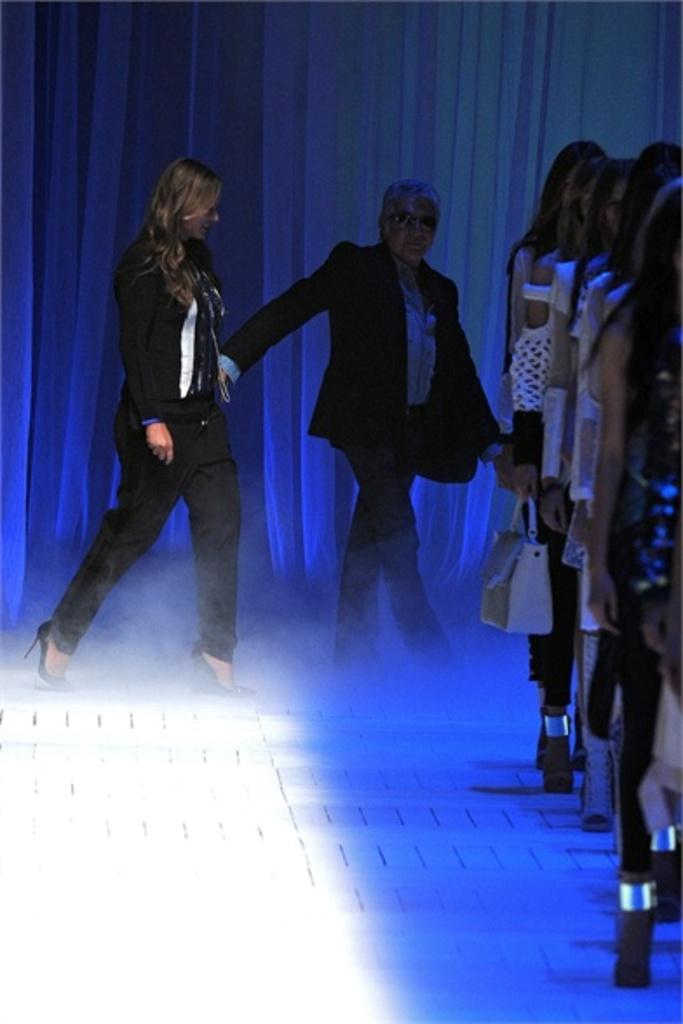What are the people on the right side of the image doing? The people on the right side of the image are standing. What are the two persons in the middle of the image doing? The two persons in the middle of the image are walking. What can be seen in the background of the image? There is a curtain in the background of the image. What is the temperature of the hair on the person in the middle of the image? There is no information about the temperature of anyone's hair in the image, nor is there any indication that the person in the middle of the image has hair. 